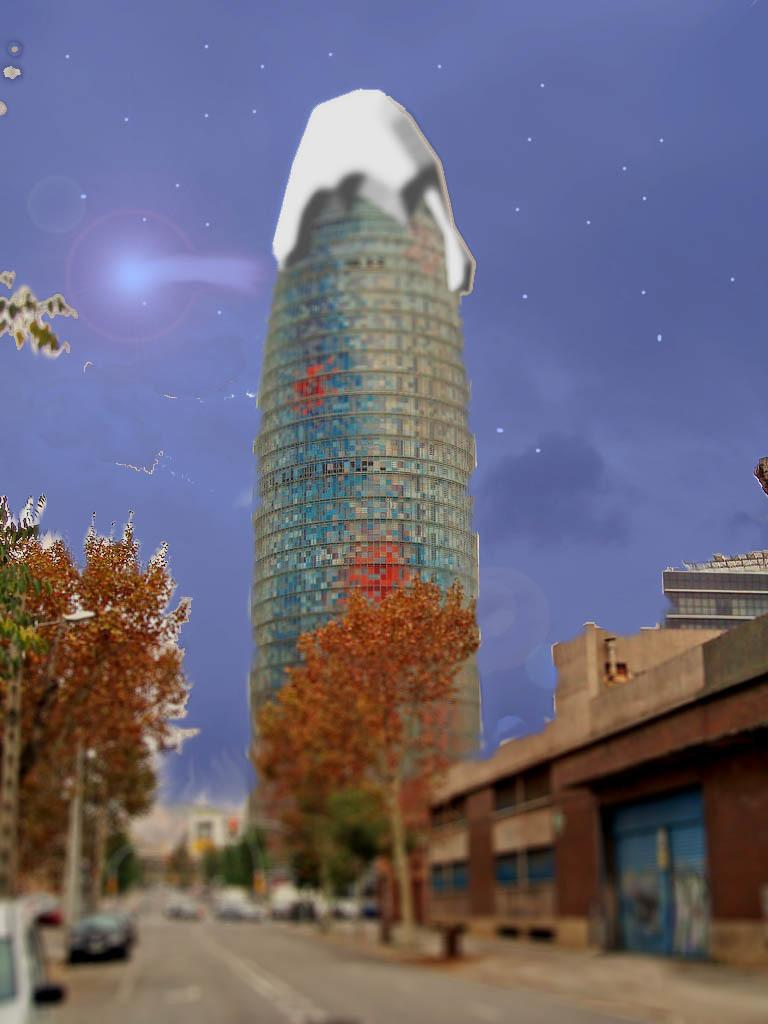What can be inferred about the image based on the first fact? The image appears to be edited, which means it may have been altered or manipulated in some way. What types of objects can be seen in the image? There are vehicles, buildings, and trees in the image. What is visible at the top of the image? The sky is visible at the top of the image. What additional detail can be observed about the sky? Stars are present in the sky. What is the position of the soda can in the image? There is no soda can present in the image, so it is not possible to determine its position. 